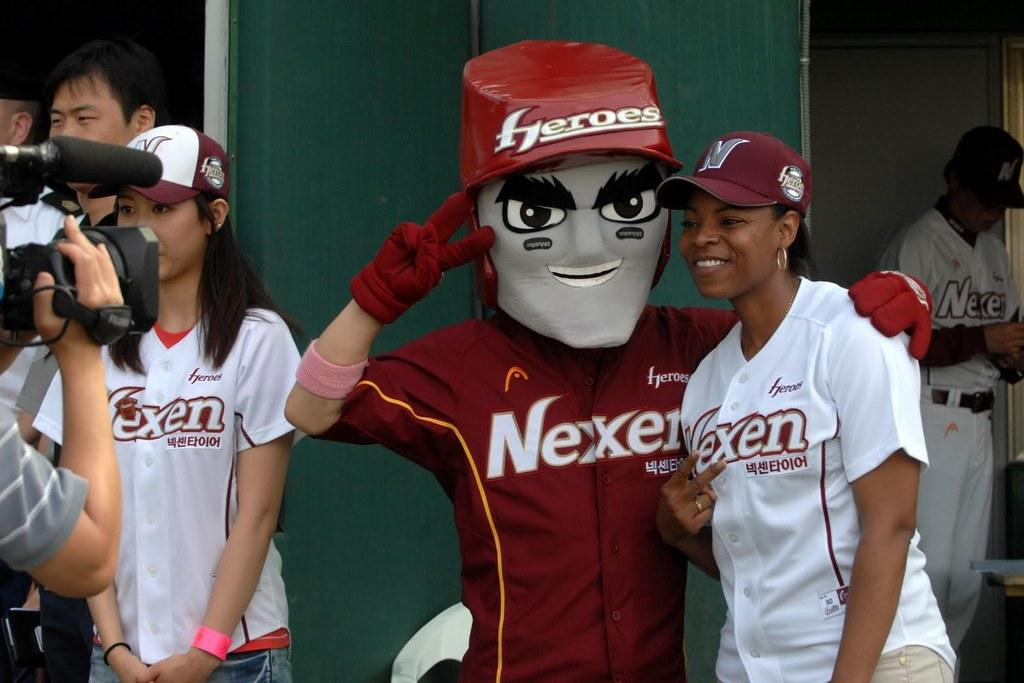<image>
Render a clear and concise summary of the photo. Several people pose for pictures wearing jerseys with the name "Nexen" on the front. 